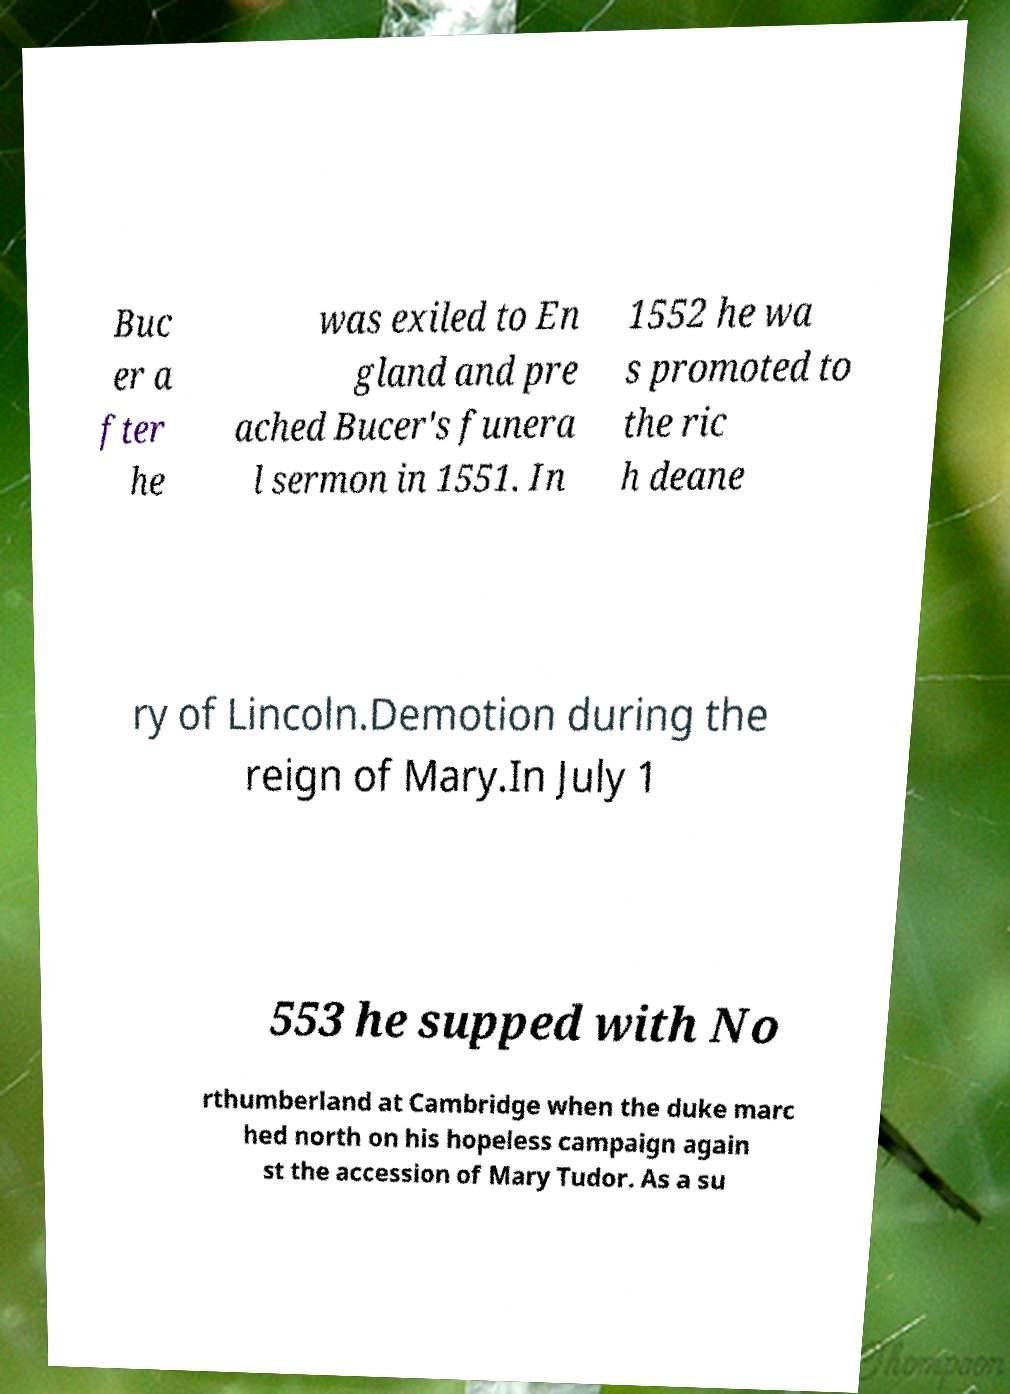Could you extract and type out the text from this image? Buc er a fter he was exiled to En gland and pre ached Bucer's funera l sermon in 1551. In 1552 he wa s promoted to the ric h deane ry of Lincoln.Demotion during the reign of Mary.In July 1 553 he supped with No rthumberland at Cambridge when the duke marc hed north on his hopeless campaign again st the accession of Mary Tudor. As a su 